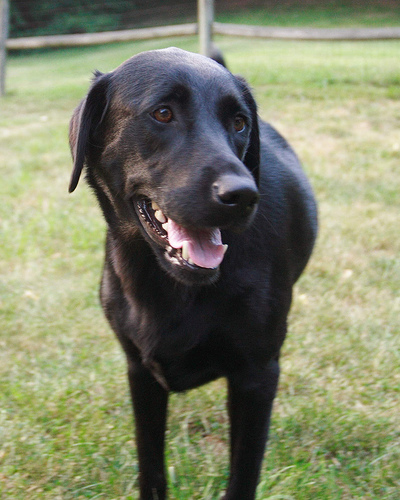<image>
Can you confirm if the fence is next to the grass? No. The fence is not positioned next to the grass. They are located in different areas of the scene. 